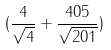<formula> <loc_0><loc_0><loc_500><loc_500>( \frac { 4 } { \sqrt { 4 } } + \frac { 4 0 5 } { \sqrt { 2 0 1 } } )</formula> 